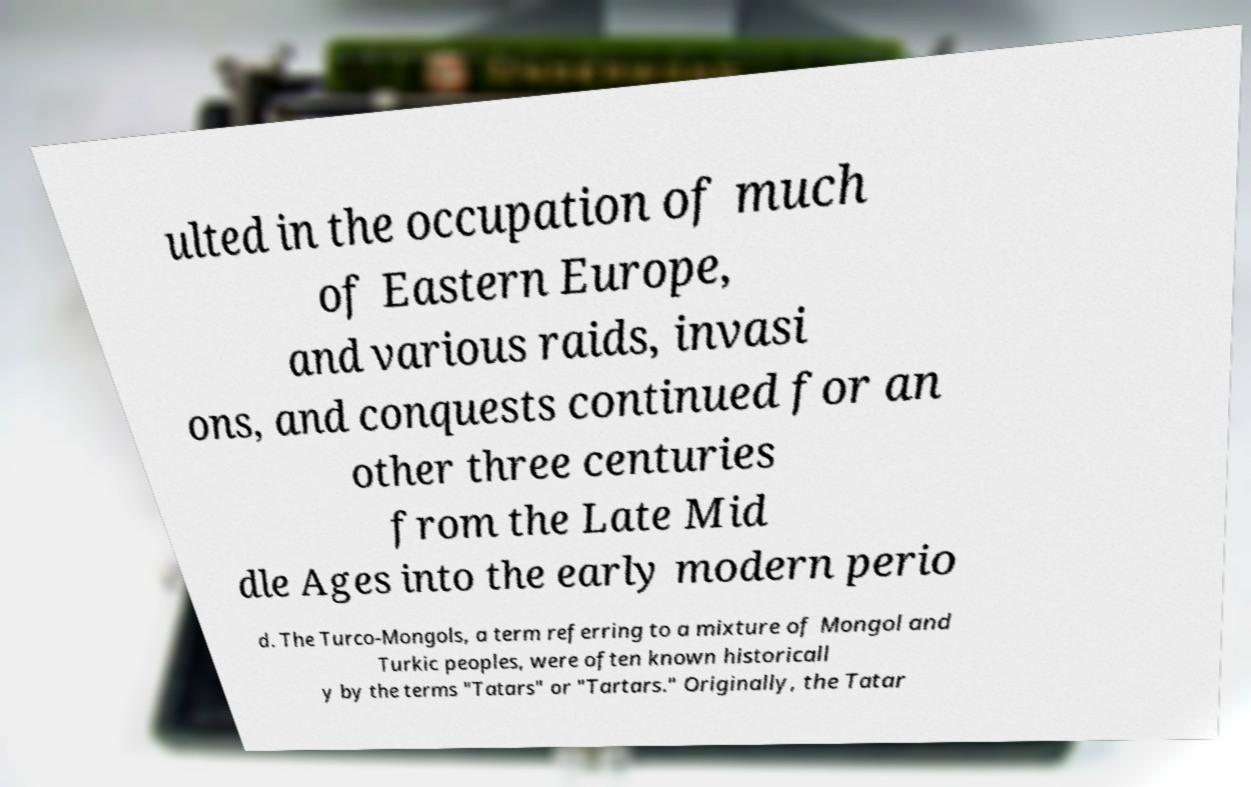What messages or text are displayed in this image? I need them in a readable, typed format. ulted in the occupation of much of Eastern Europe, and various raids, invasi ons, and conquests continued for an other three centuries from the Late Mid dle Ages into the early modern perio d. The Turco-Mongols, a term referring to a mixture of Mongol and Turkic peoples, were often known historicall y by the terms "Tatars" or "Tartars." Originally, the Tatar 